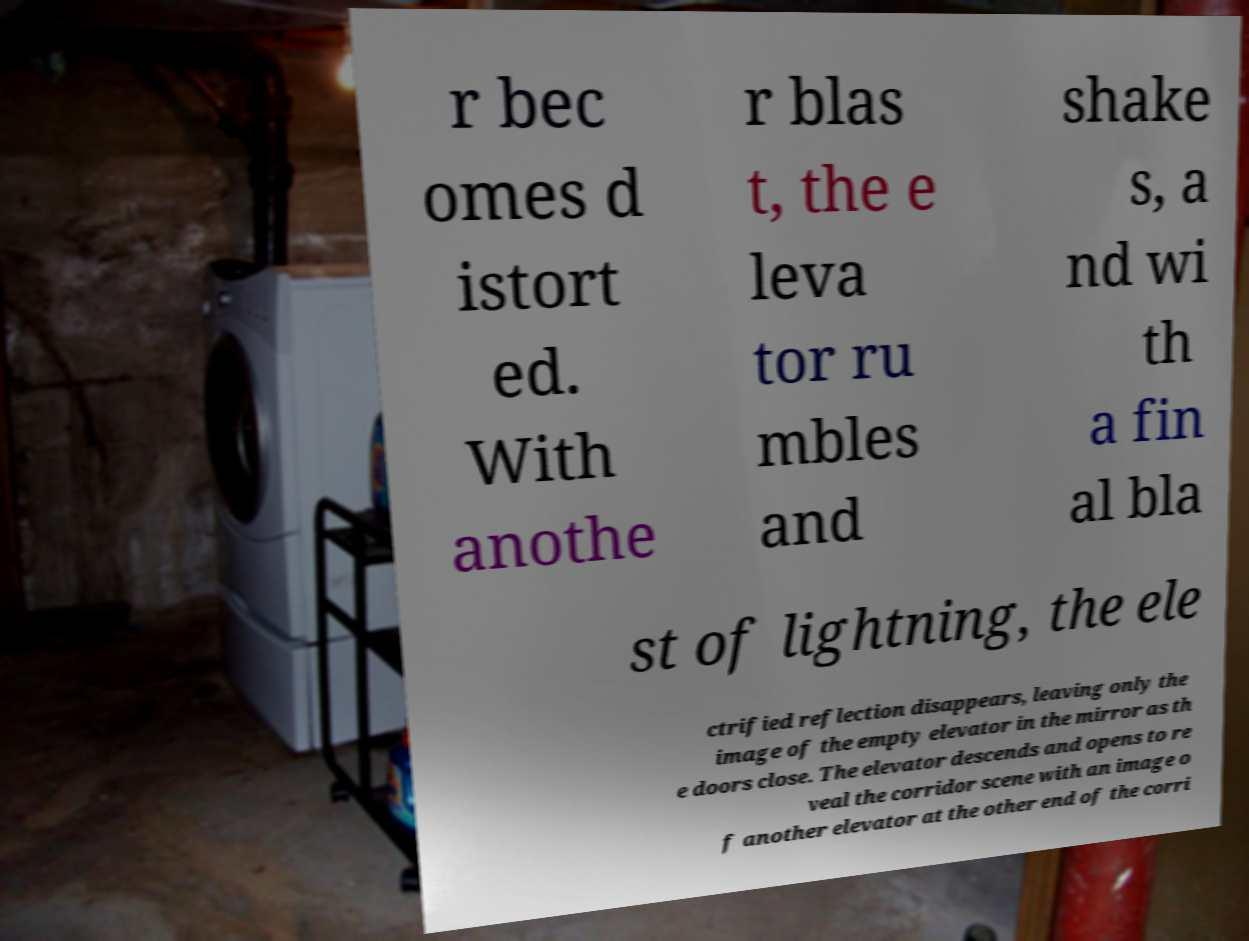I need the written content from this picture converted into text. Can you do that? r bec omes d istort ed. With anothe r blas t, the e leva tor ru mbles and shake s, a nd wi th a fin al bla st of lightning, the ele ctrified reflection disappears, leaving only the image of the empty elevator in the mirror as th e doors close. The elevator descends and opens to re veal the corridor scene with an image o f another elevator at the other end of the corri 